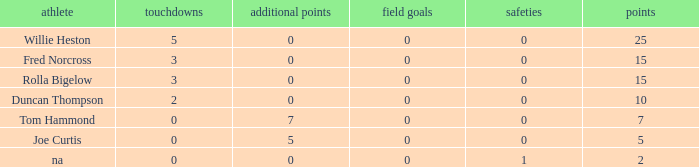How many Touchdowns have a Player of rolla bigelow, and an Extra points smaller than 0? None. 